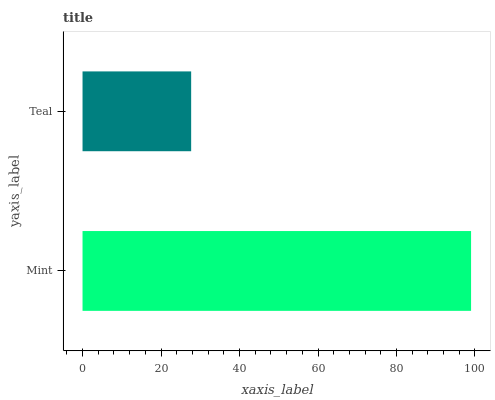Is Teal the minimum?
Answer yes or no. Yes. Is Mint the maximum?
Answer yes or no. Yes. Is Teal the maximum?
Answer yes or no. No. Is Mint greater than Teal?
Answer yes or no. Yes. Is Teal less than Mint?
Answer yes or no. Yes. Is Teal greater than Mint?
Answer yes or no. No. Is Mint less than Teal?
Answer yes or no. No. Is Mint the high median?
Answer yes or no. Yes. Is Teal the low median?
Answer yes or no. Yes. Is Teal the high median?
Answer yes or no. No. Is Mint the low median?
Answer yes or no. No. 